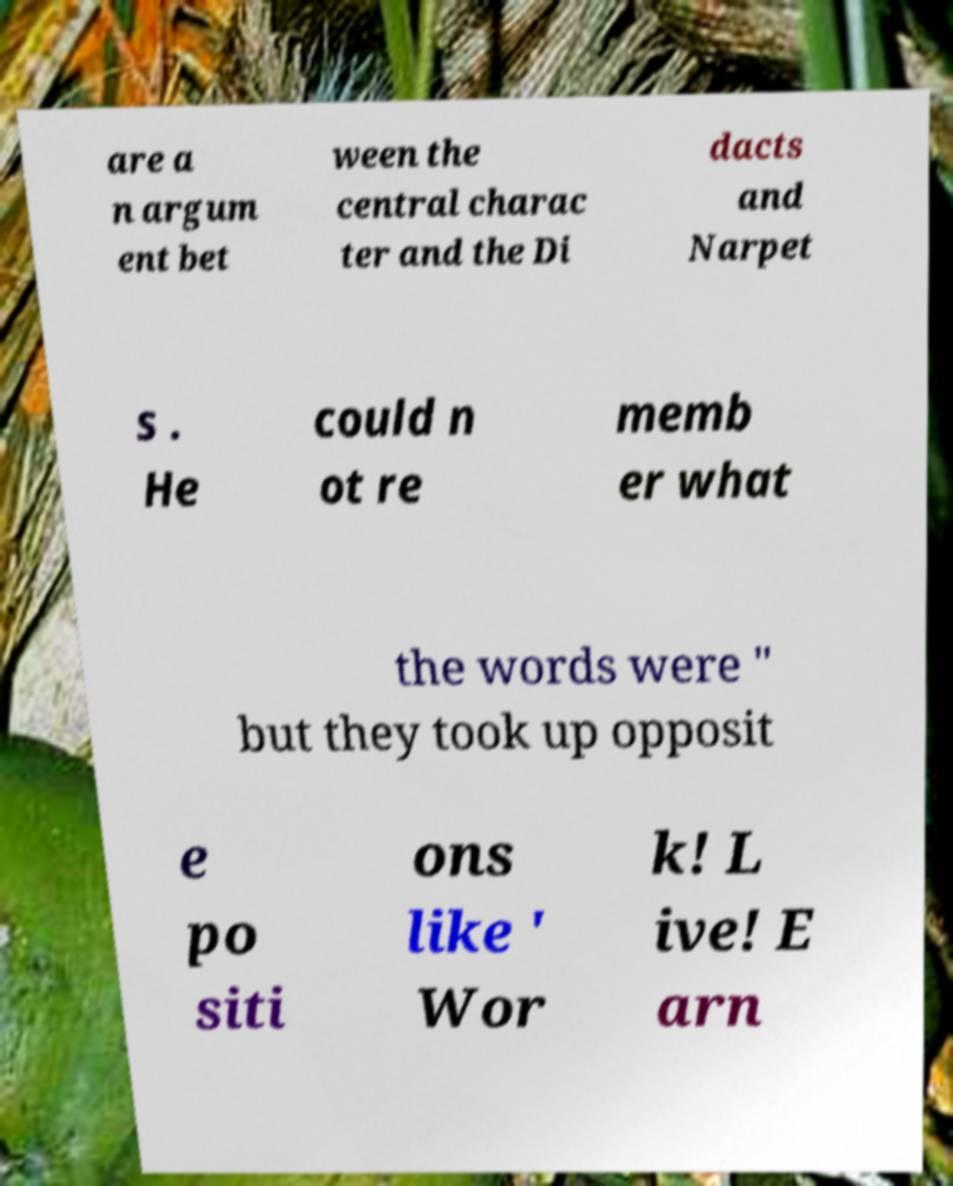There's text embedded in this image that I need extracted. Can you transcribe it verbatim? are a n argum ent bet ween the central charac ter and the Di dacts and Narpet s . He could n ot re memb er what the words were " but they took up opposit e po siti ons like ' Wor k! L ive! E arn 